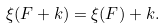Convert formula to latex. <formula><loc_0><loc_0><loc_500><loc_500>\xi ( F + k ) = \xi ( F ) + k .</formula> 